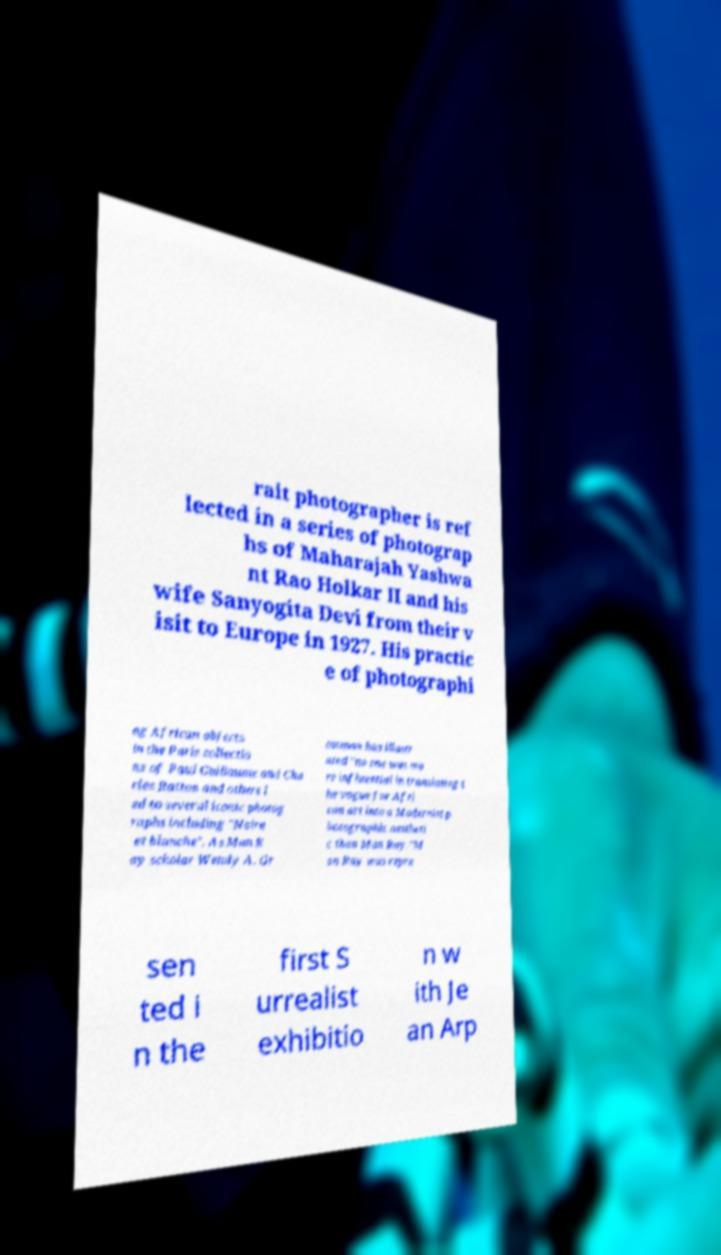Please read and relay the text visible in this image. What does it say? rait photographer is ref lected in a series of photograp hs of Maharajah Yashwa nt Rao Holkar II and his wife Sanyogita Devi from their v isit to Europe in 1927. His practic e of photographi ng African objects in the Paris collectio ns of Paul Guillaume and Cha rles Ratton and others l ed to several iconic photog raphs including "Noire et blanche". As Man R ay scholar Wendy A. Gr ossman has illustr ated "no one was mo re influential in translating t he vogue for Afri can art into a Modernist p hotographic aestheti c than Man Ray."M an Ray was repre sen ted i n the first S urrealist exhibitio n w ith Je an Arp 